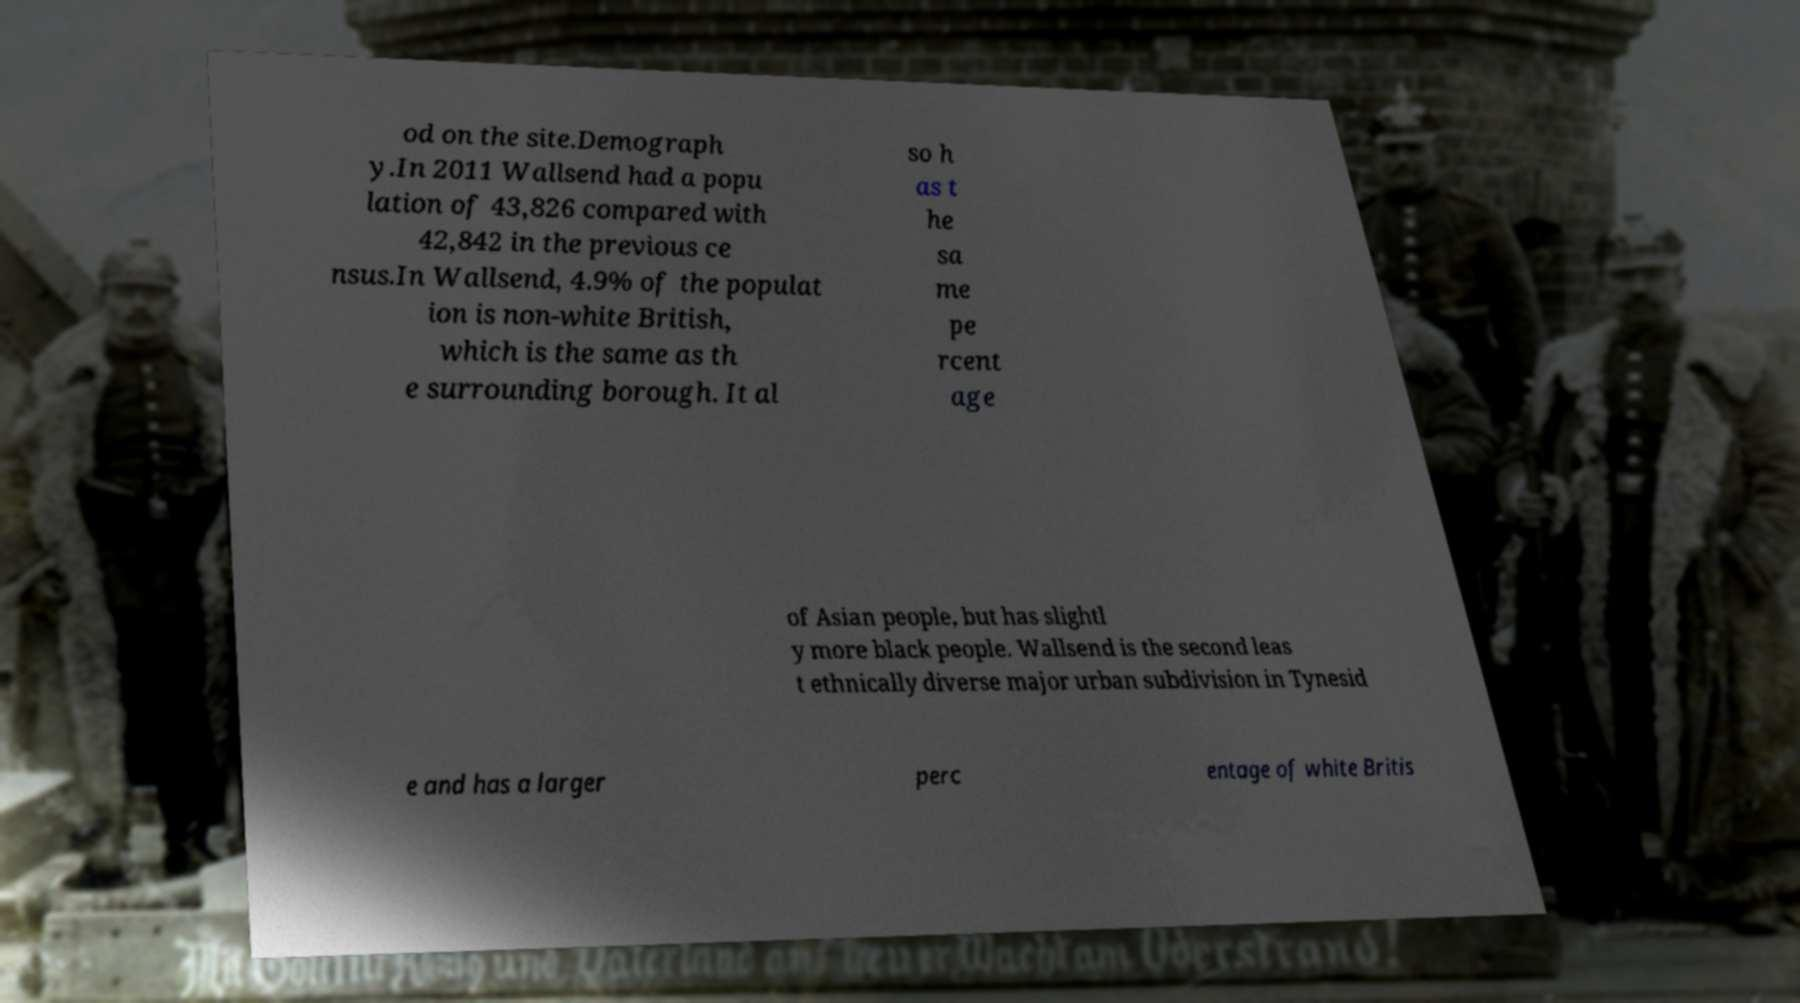Please read and relay the text visible in this image. What does it say? od on the site.Demograph y.In 2011 Wallsend had a popu lation of 43,826 compared with 42,842 in the previous ce nsus.In Wallsend, 4.9% of the populat ion is non-white British, which is the same as th e surrounding borough. It al so h as t he sa me pe rcent age of Asian people, but has slightl y more black people. Wallsend is the second leas t ethnically diverse major urban subdivision in Tynesid e and has a larger perc entage of white Britis 